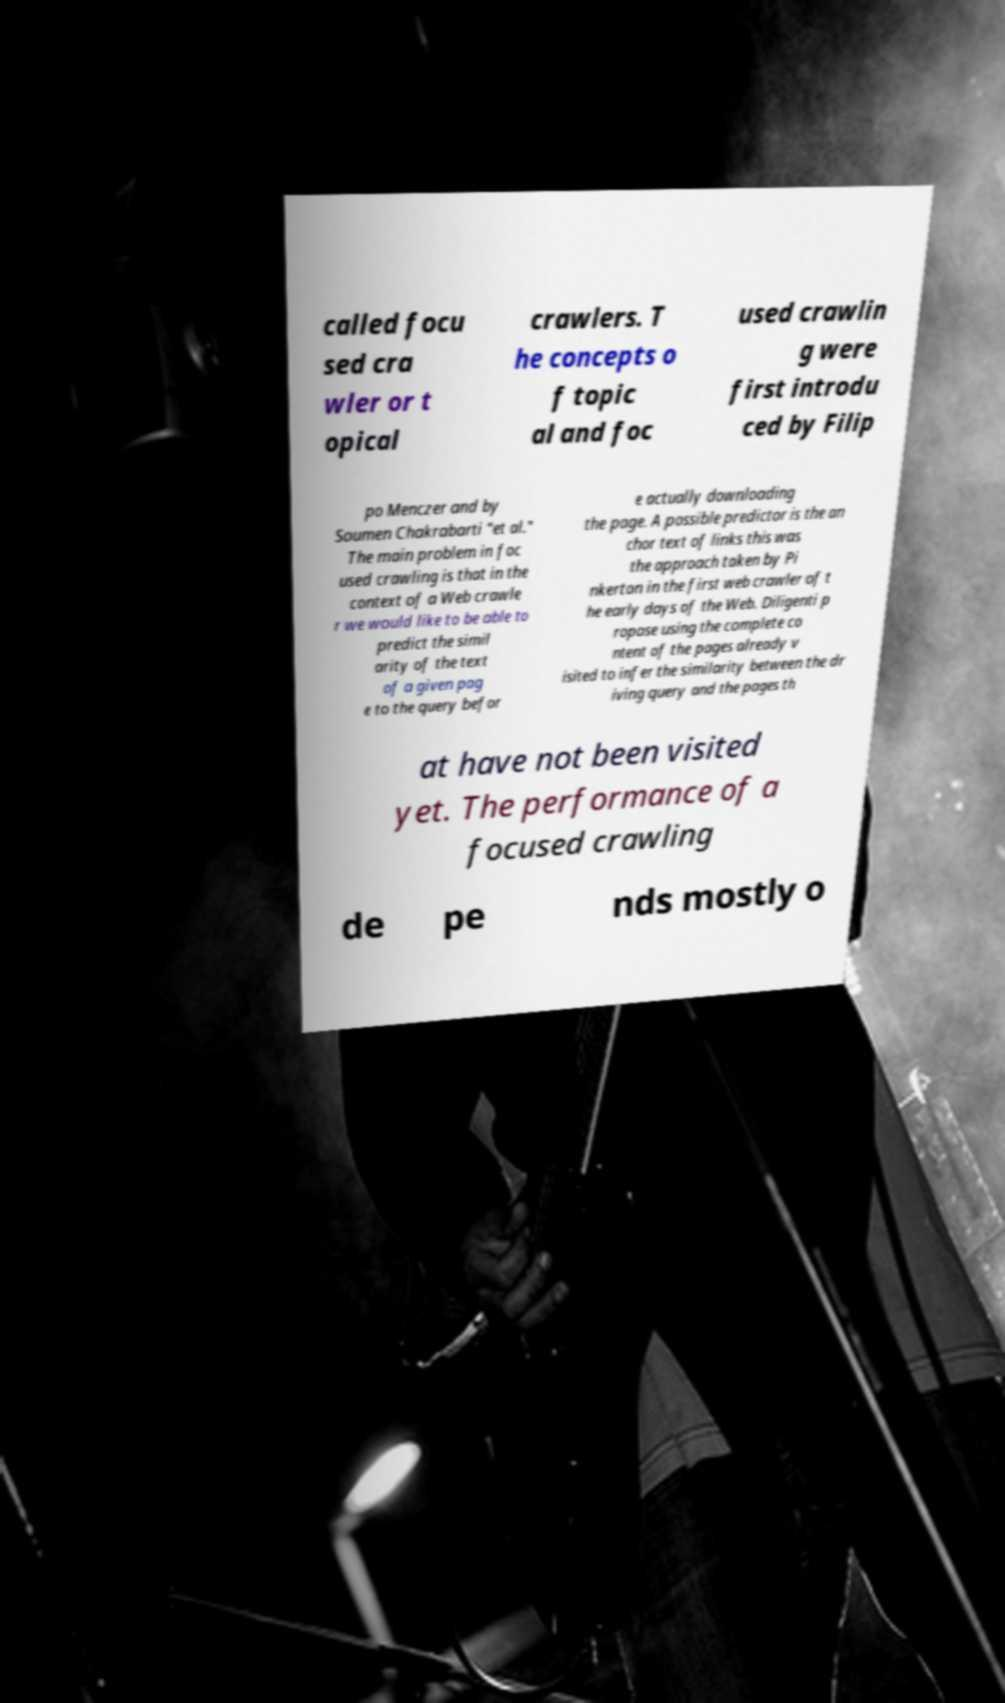Could you assist in decoding the text presented in this image and type it out clearly? called focu sed cra wler or t opical crawlers. T he concepts o f topic al and foc used crawlin g were first introdu ced by Filip po Menczer and by Soumen Chakrabarti "et al." The main problem in foc used crawling is that in the context of a Web crawle r we would like to be able to predict the simil arity of the text of a given pag e to the query befor e actually downloading the page. A possible predictor is the an chor text of links this was the approach taken by Pi nkerton in the first web crawler of t he early days of the Web. Diligenti p ropose using the complete co ntent of the pages already v isited to infer the similarity between the dr iving query and the pages th at have not been visited yet. The performance of a focused crawling de pe nds mostly o 